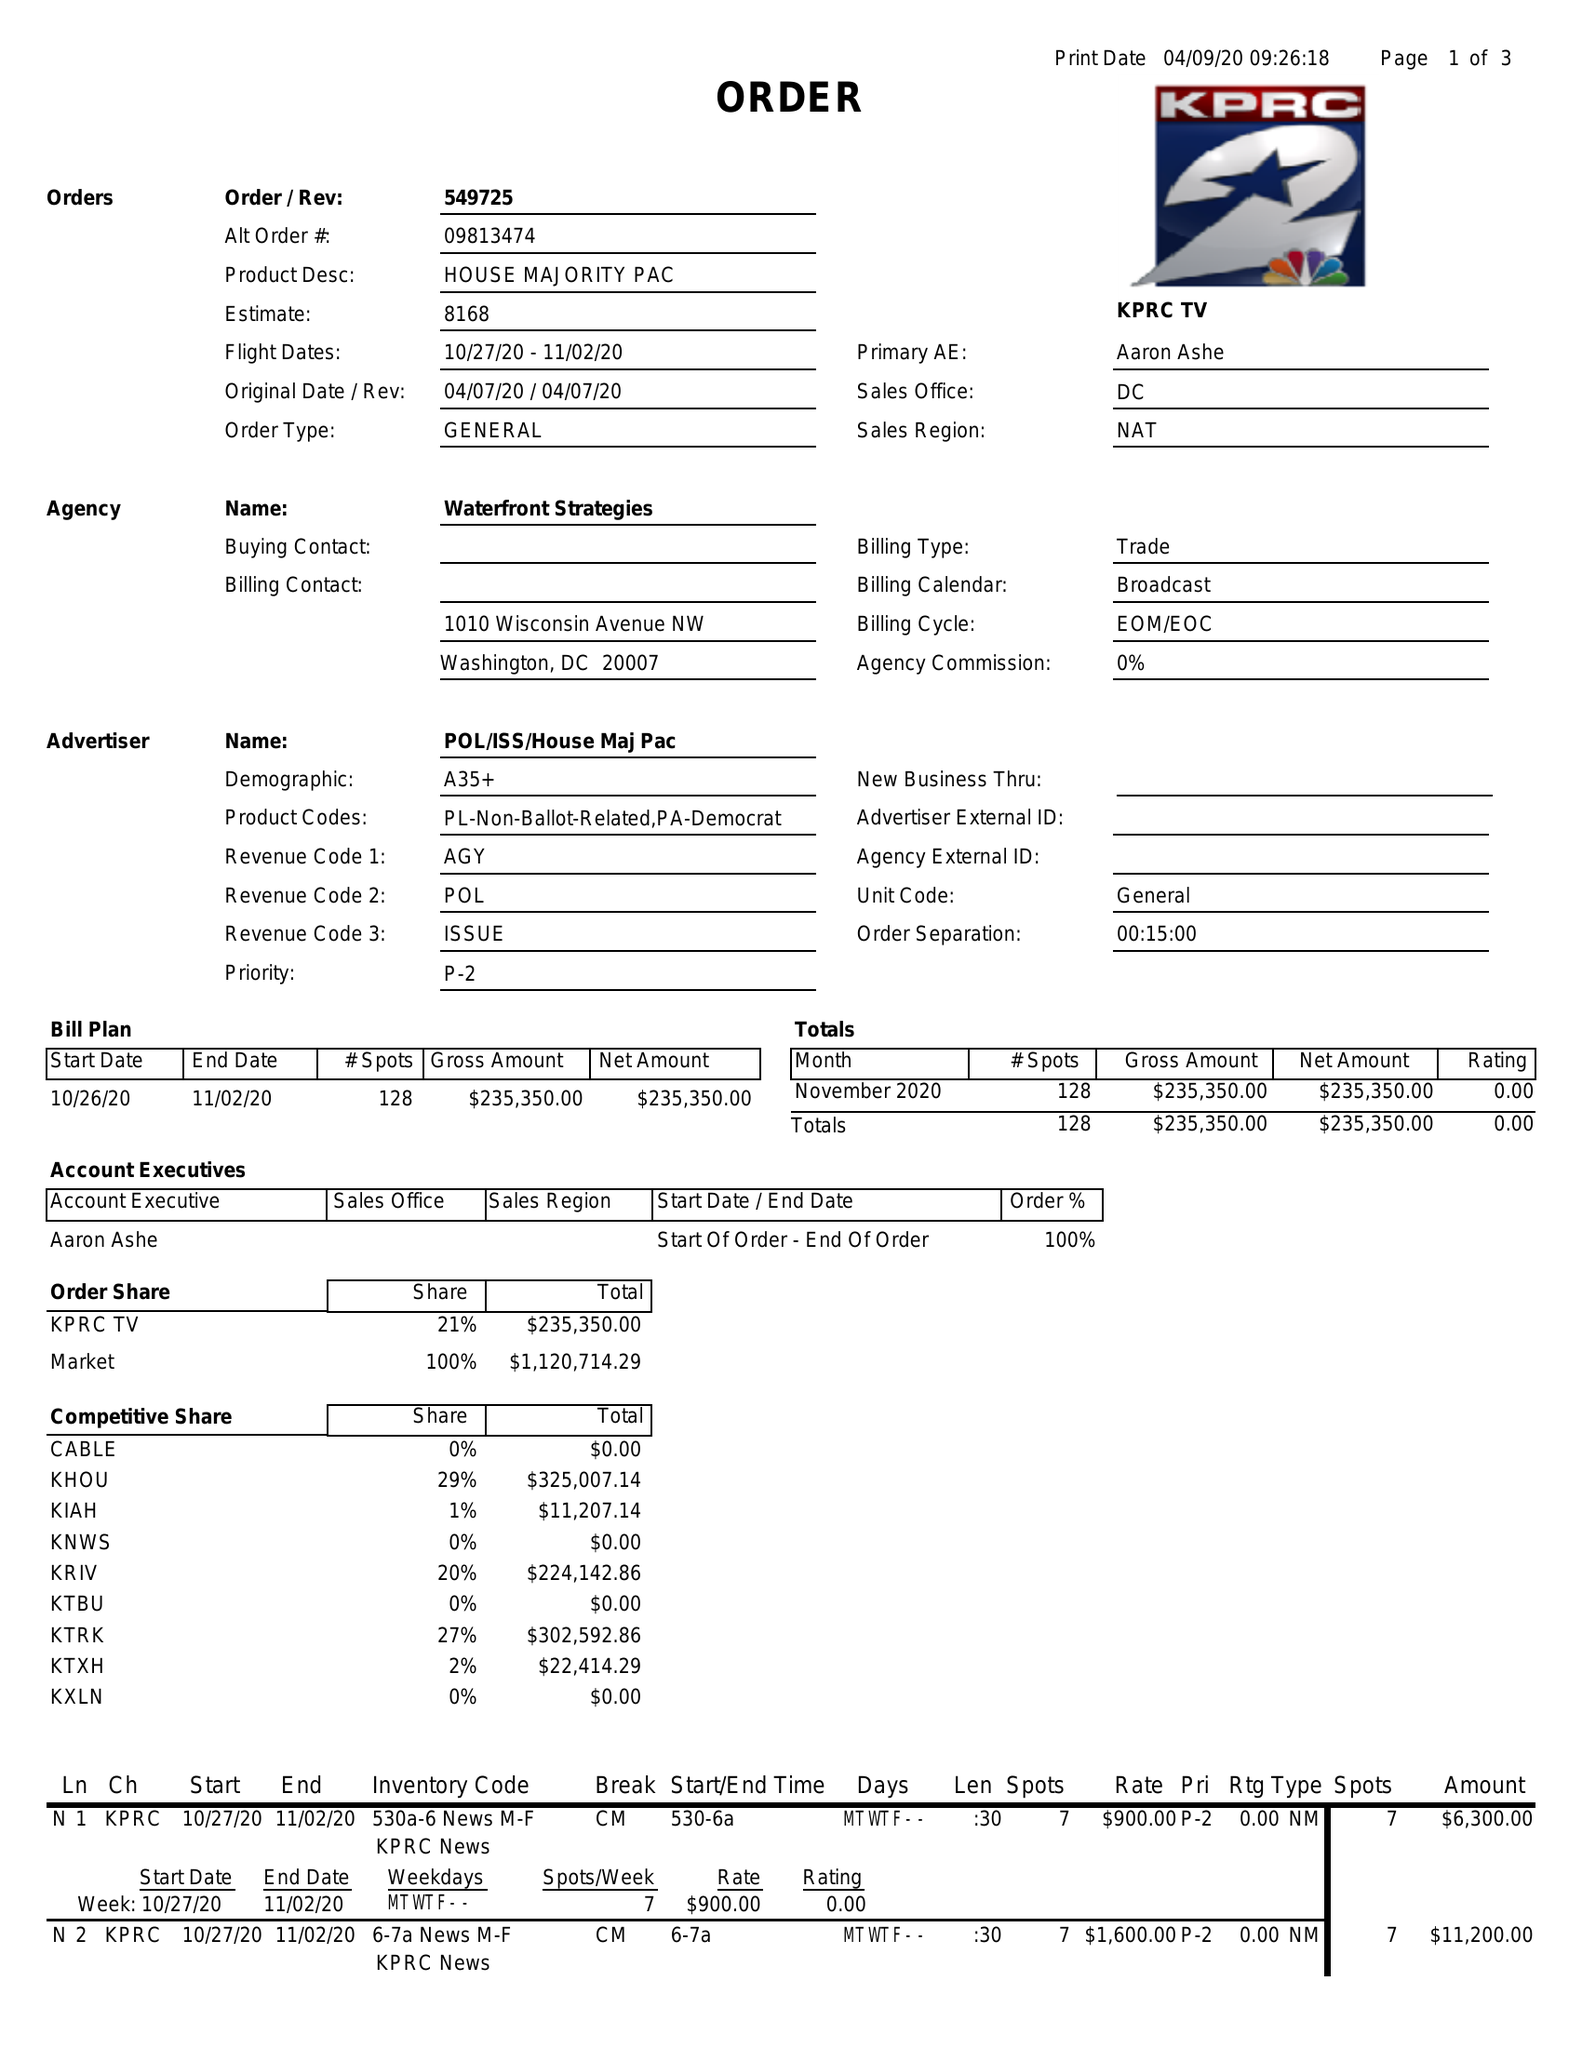What is the value for the flight_from?
Answer the question using a single word or phrase. 10/27/20 